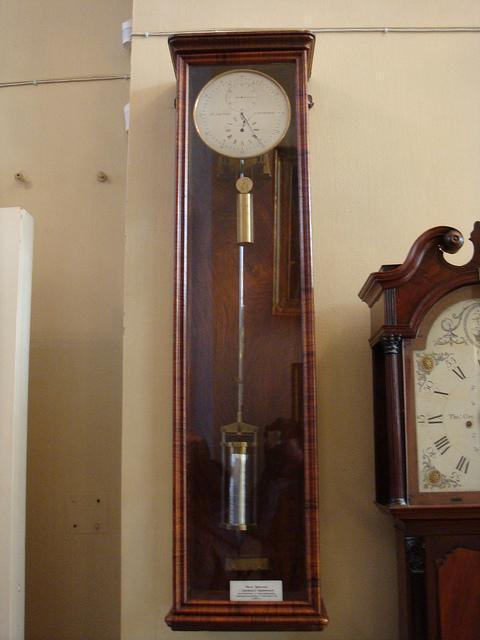How many clocks are there in the picture?
Give a very brief answer. 2. How many clocks can you see?
Give a very brief answer. 2. 